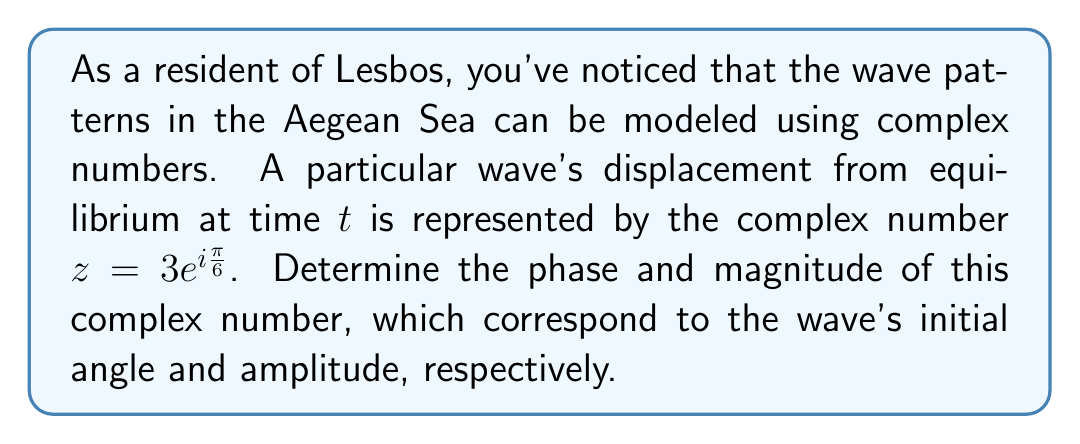What is the answer to this math problem? To solve this problem, let's break it down into steps:

1) The complex number is given in polar form: $z = 3e^{i\frac{\pi}{6}}$

2) In general, a complex number in polar form is written as $z = re^{i\theta}$, where:
   - $r$ is the magnitude (or modulus)
   - $\theta$ is the phase (or argument)

3) Comparing our given number to this general form, we can see that:
   - $r = 3$
   - $\theta = \frac{\pi}{6}$

4) The magnitude $r$ represents the amplitude of the wave, which is the maximum displacement from equilibrium.

5) The phase $\theta$ represents the initial angle of the wave at time $t=0$. It's given in radians, but we can convert it to degrees:

   $$\frac{\pi}{6} \text{ radians} = \frac{\pi}{6} \cdot \frac{180^{\circ}}{\pi} = 30^{\circ}$$

6) To verify these results, we can also express the complex number in rectangular form:

   $$z = 3(\cos(\frac{\pi}{6}) + i\sin(\frac{\pi}{6}))$$
   $$z = 3(\frac{\sqrt{3}}{2} + i\frac{1}{2})$$
   $$z = \frac{3\sqrt{3}}{2} + \frac{3i}{2}$$

   The magnitude can be calculated as $\sqrt{(\frac{3\sqrt{3}}{2})^2 + (\frac{3}{2})^2} = 3$, confirming our result.
Answer: The phase of the complex number is $\frac{\pi}{6}$ radians or $30^{\circ}$, and its magnitude is 3. 